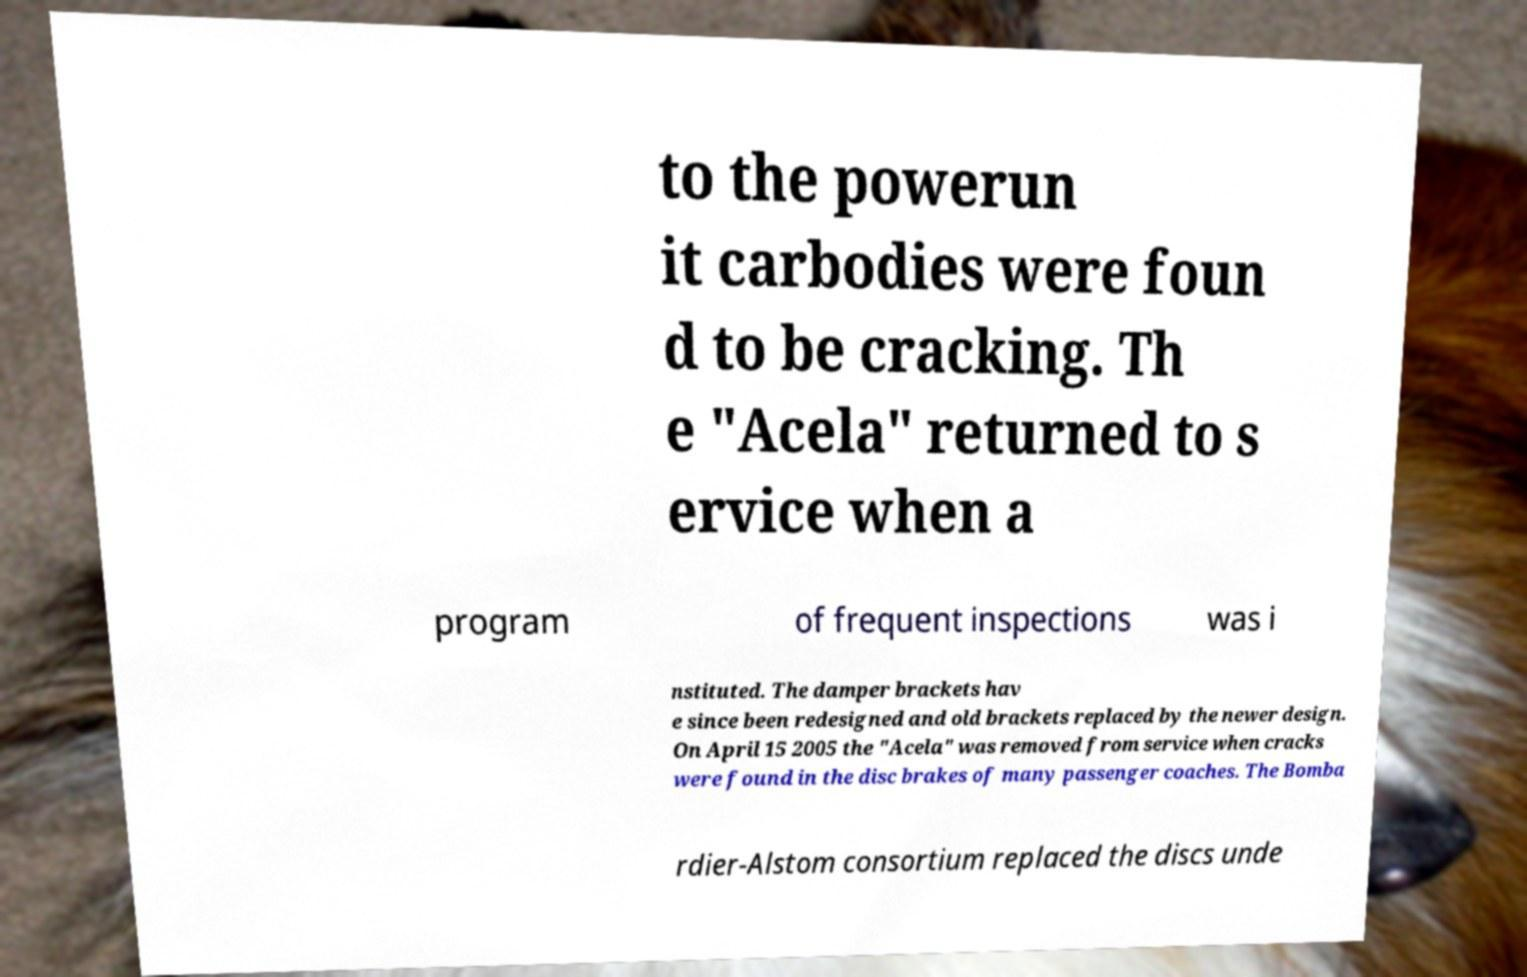I need the written content from this picture converted into text. Can you do that? to the powerun it carbodies were foun d to be cracking. Th e "Acela" returned to s ervice when a program of frequent inspections was i nstituted. The damper brackets hav e since been redesigned and old brackets replaced by the newer design. On April 15 2005 the "Acela" was removed from service when cracks were found in the disc brakes of many passenger coaches. The Bomba rdier-Alstom consortium replaced the discs unde 